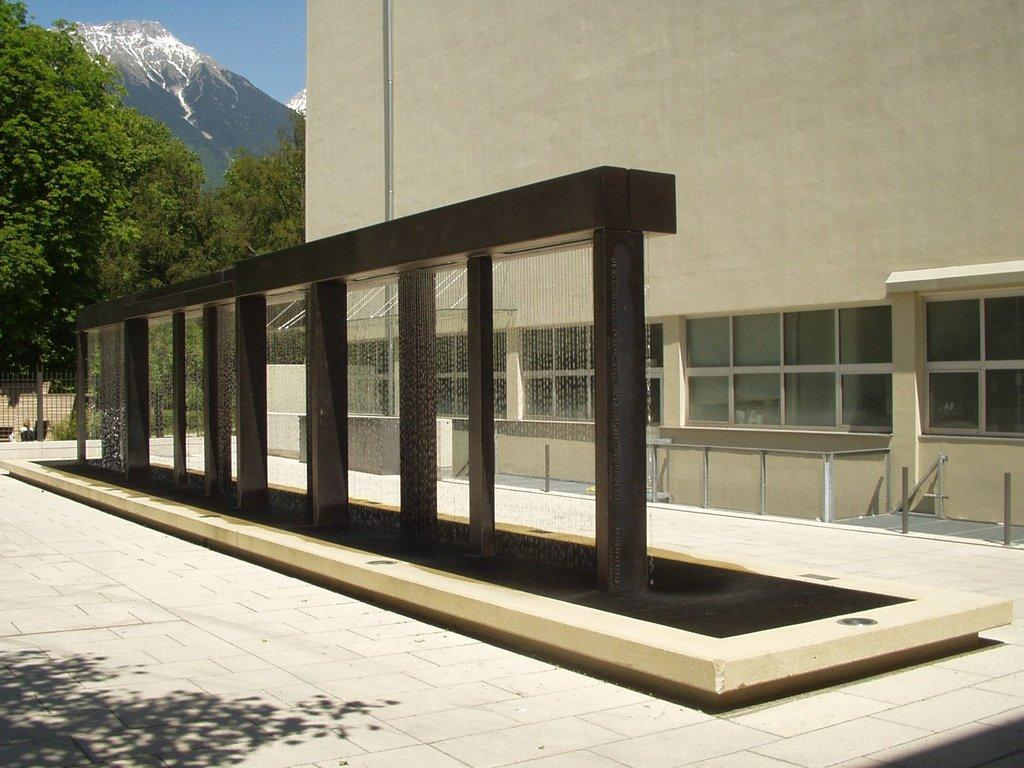What type of structure is visible in the image? There is a building in the image. What natural elements can be seen in the image? There are trees and a hill in the image. What is the color of the sky in the image? The sky is black and blue in the image. Can you tell me how many roses are on the hill in the image? There are no roses present in the image; it features a building, trees, and a hill with no visible flowers. What type of bucket is used to collect water from the building in the image? There is no bucket present in the image, and the building is not depicted as having any water collection system. 